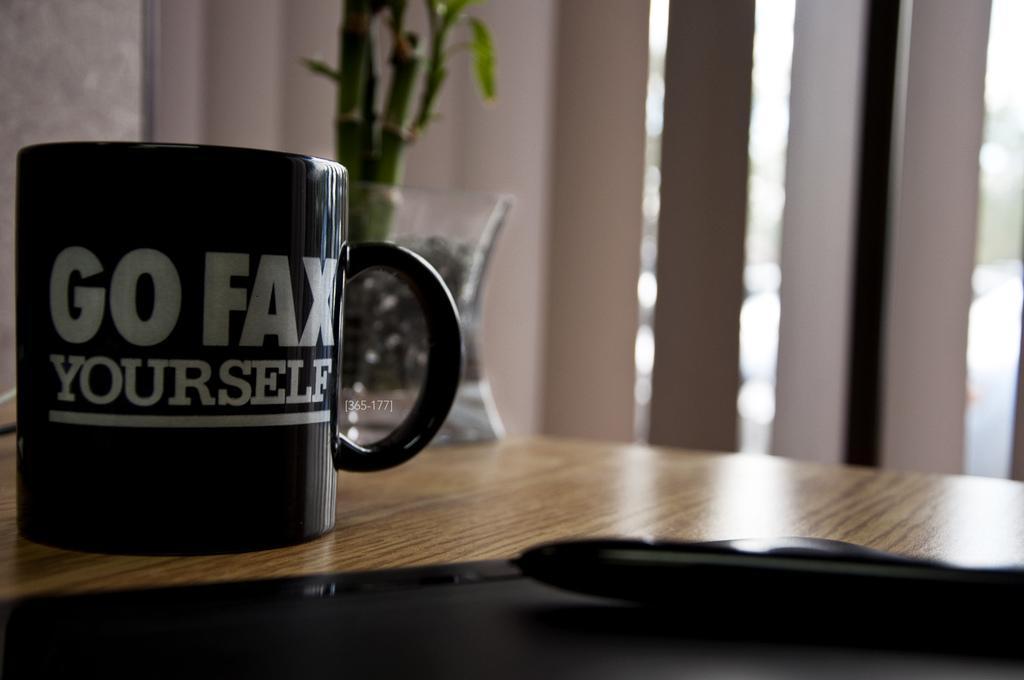Describe this image in one or two sentences. At the bottom of the image we can see a table. On the table we can see a cup, pot, plant and some objects. In the background of the image we can see the wall. 